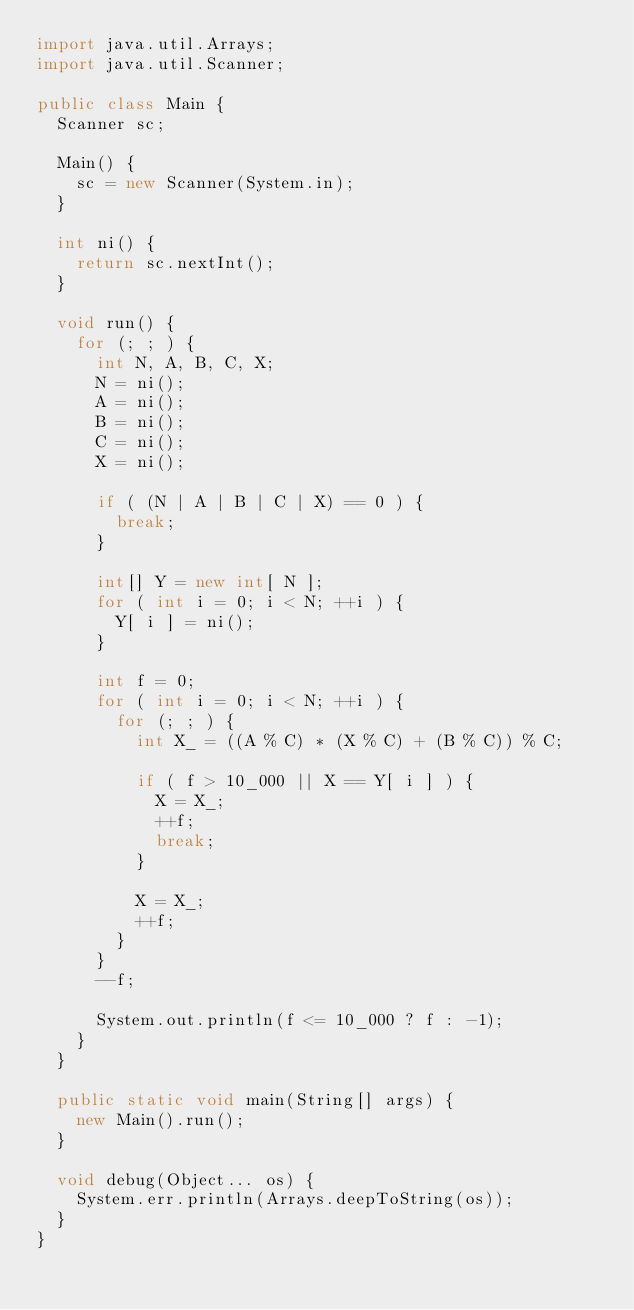Convert code to text. <code><loc_0><loc_0><loc_500><loc_500><_Java_>import java.util.Arrays;
import java.util.Scanner;

public class Main {
  Scanner sc;

  Main() {
    sc = new Scanner(System.in);
  }

  int ni() {
    return sc.nextInt();
  }

  void run() {
    for (; ; ) {
      int N, A, B, C, X;
      N = ni();
      A = ni();
      B = ni();
      C = ni();
      X = ni();

      if ( (N | A | B | C | X) == 0 ) {
        break;
      }

      int[] Y = new int[ N ];
      for ( int i = 0; i < N; ++i ) {
        Y[ i ] = ni();
      }

      int f = 0;
      for ( int i = 0; i < N; ++i ) {
        for (; ; ) {
          int X_ = ((A % C) * (X % C) + (B % C)) % C;

          if ( f > 10_000 || X == Y[ i ] ) {
            X = X_;
            ++f;
            break;
          }

          X = X_;
          ++f;
        }
      }
      --f;

      System.out.println(f <= 10_000 ? f : -1);
    }
  }

  public static void main(String[] args) {
    new Main().run();
  }

  void debug(Object... os) {
    System.err.println(Arrays.deepToString(os));
  }
}</code> 